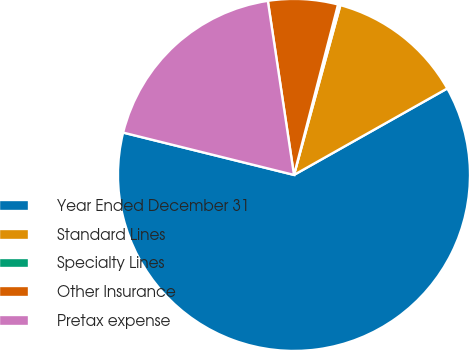Convert chart. <chart><loc_0><loc_0><loc_500><loc_500><pie_chart><fcel>Year Ended December 31<fcel>Standard Lines<fcel>Specialty Lines<fcel>Other Insurance<fcel>Pretax expense<nl><fcel>62.04%<fcel>12.58%<fcel>0.22%<fcel>6.4%<fcel>18.76%<nl></chart> 